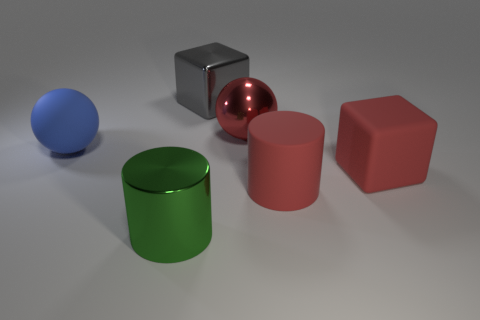How many other objects are the same size as the red shiny thing?
Your answer should be compact. 5. Do the large matte cylinder and the big cube in front of the large gray metallic thing have the same color?
Your answer should be very brief. Yes. What number of objects are either large green matte cylinders or balls?
Make the answer very short. 2. Is there anything else of the same color as the large metal block?
Ensure brevity in your answer.  No. Does the big red ball have the same material as the thing to the left of the green shiny object?
Your response must be concise. No. There is a shiny thing that is on the left side of the block behind the red cube; what shape is it?
Ensure brevity in your answer.  Cylinder. The large metal thing that is behind the large red matte cube and to the left of the big shiny ball has what shape?
Make the answer very short. Cube. What number of objects are small rubber cylinders or spheres in front of the big shiny ball?
Provide a short and direct response. 1. What material is the blue object that is the same shape as the red metal thing?
Ensure brevity in your answer.  Rubber. There is a large red thing that is behind the large rubber cylinder and left of the red cube; what material is it?
Make the answer very short. Metal. 